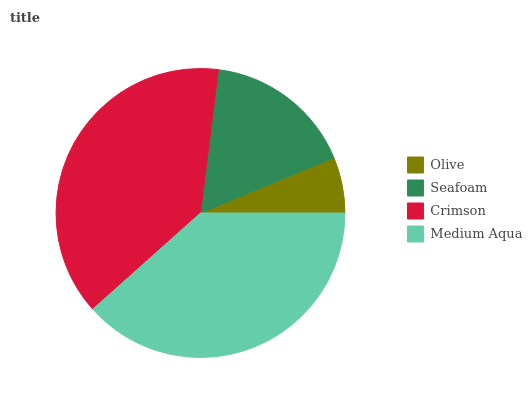Is Olive the minimum?
Answer yes or no. Yes. Is Crimson the maximum?
Answer yes or no. Yes. Is Seafoam the minimum?
Answer yes or no. No. Is Seafoam the maximum?
Answer yes or no. No. Is Seafoam greater than Olive?
Answer yes or no. Yes. Is Olive less than Seafoam?
Answer yes or no. Yes. Is Olive greater than Seafoam?
Answer yes or no. No. Is Seafoam less than Olive?
Answer yes or no. No. Is Medium Aqua the high median?
Answer yes or no. Yes. Is Seafoam the low median?
Answer yes or no. Yes. Is Seafoam the high median?
Answer yes or no. No. Is Crimson the low median?
Answer yes or no. No. 